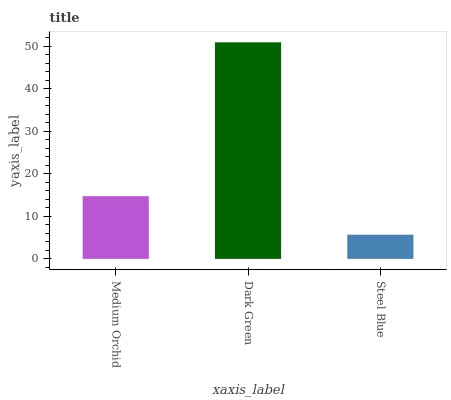Is Steel Blue the minimum?
Answer yes or no. Yes. Is Dark Green the maximum?
Answer yes or no. Yes. Is Dark Green the minimum?
Answer yes or no. No. Is Steel Blue the maximum?
Answer yes or no. No. Is Dark Green greater than Steel Blue?
Answer yes or no. Yes. Is Steel Blue less than Dark Green?
Answer yes or no. Yes. Is Steel Blue greater than Dark Green?
Answer yes or no. No. Is Dark Green less than Steel Blue?
Answer yes or no. No. Is Medium Orchid the high median?
Answer yes or no. Yes. Is Medium Orchid the low median?
Answer yes or no. Yes. Is Steel Blue the high median?
Answer yes or no. No. Is Dark Green the low median?
Answer yes or no. No. 